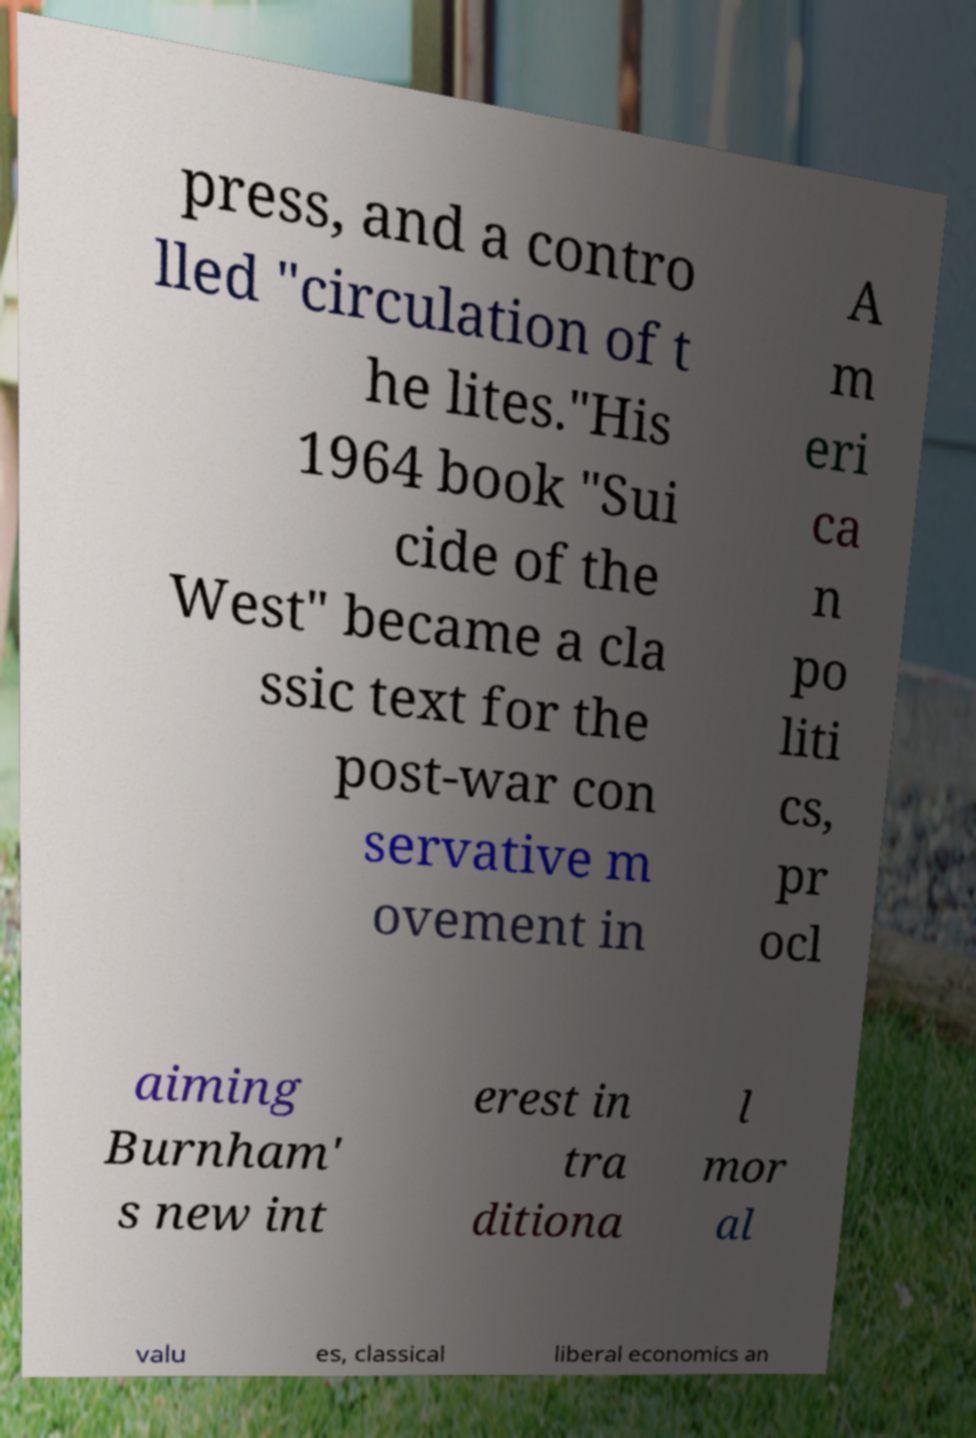Please read and relay the text visible in this image. What does it say? press, and a contro lled "circulation of t he lites."His 1964 book "Sui cide of the West" became a cla ssic text for the post-war con servative m ovement in A m eri ca n po liti cs, pr ocl aiming Burnham' s new int erest in tra ditiona l mor al valu es, classical liberal economics an 